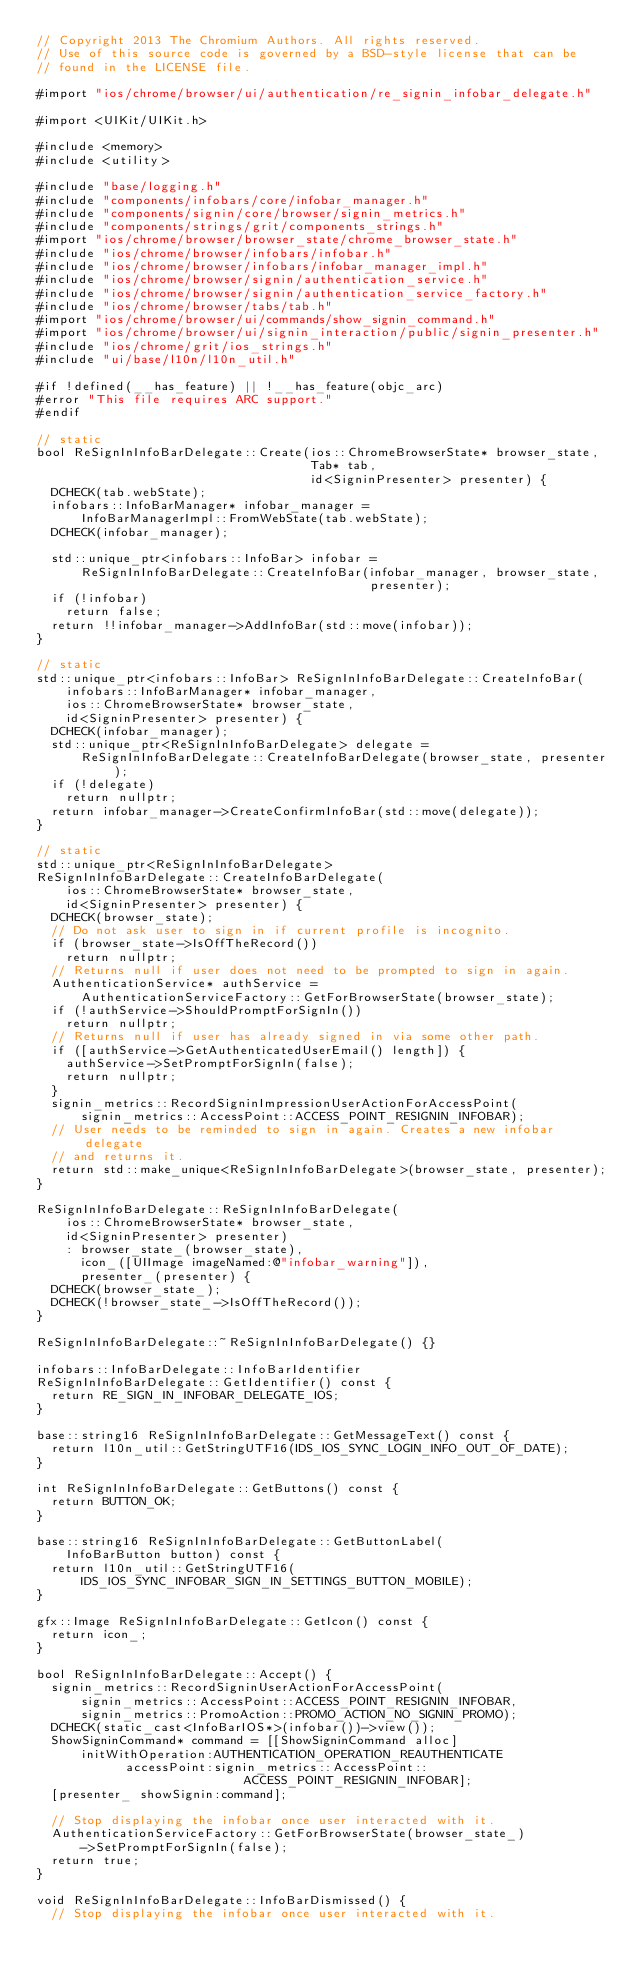<code> <loc_0><loc_0><loc_500><loc_500><_ObjectiveC_>// Copyright 2013 The Chromium Authors. All rights reserved.
// Use of this source code is governed by a BSD-style license that can be
// found in the LICENSE file.

#import "ios/chrome/browser/ui/authentication/re_signin_infobar_delegate.h"

#import <UIKit/UIKit.h>

#include <memory>
#include <utility>

#include "base/logging.h"
#include "components/infobars/core/infobar_manager.h"
#include "components/signin/core/browser/signin_metrics.h"
#include "components/strings/grit/components_strings.h"
#import "ios/chrome/browser/browser_state/chrome_browser_state.h"
#include "ios/chrome/browser/infobars/infobar.h"
#include "ios/chrome/browser/infobars/infobar_manager_impl.h"
#include "ios/chrome/browser/signin/authentication_service.h"
#include "ios/chrome/browser/signin/authentication_service_factory.h"
#include "ios/chrome/browser/tabs/tab.h"
#import "ios/chrome/browser/ui/commands/show_signin_command.h"
#import "ios/chrome/browser/ui/signin_interaction/public/signin_presenter.h"
#include "ios/chrome/grit/ios_strings.h"
#include "ui/base/l10n/l10n_util.h"

#if !defined(__has_feature) || !__has_feature(objc_arc)
#error "This file requires ARC support."
#endif

// static
bool ReSignInInfoBarDelegate::Create(ios::ChromeBrowserState* browser_state,
                                     Tab* tab,
                                     id<SigninPresenter> presenter) {
  DCHECK(tab.webState);
  infobars::InfoBarManager* infobar_manager =
      InfoBarManagerImpl::FromWebState(tab.webState);
  DCHECK(infobar_manager);

  std::unique_ptr<infobars::InfoBar> infobar =
      ReSignInInfoBarDelegate::CreateInfoBar(infobar_manager, browser_state,
                                             presenter);
  if (!infobar)
    return false;
  return !!infobar_manager->AddInfoBar(std::move(infobar));
}

// static
std::unique_ptr<infobars::InfoBar> ReSignInInfoBarDelegate::CreateInfoBar(
    infobars::InfoBarManager* infobar_manager,
    ios::ChromeBrowserState* browser_state,
    id<SigninPresenter> presenter) {
  DCHECK(infobar_manager);
  std::unique_ptr<ReSignInInfoBarDelegate> delegate =
      ReSignInInfoBarDelegate::CreateInfoBarDelegate(browser_state, presenter);
  if (!delegate)
    return nullptr;
  return infobar_manager->CreateConfirmInfoBar(std::move(delegate));
}

// static
std::unique_ptr<ReSignInInfoBarDelegate>
ReSignInInfoBarDelegate::CreateInfoBarDelegate(
    ios::ChromeBrowserState* browser_state,
    id<SigninPresenter> presenter) {
  DCHECK(browser_state);
  // Do not ask user to sign in if current profile is incognito.
  if (browser_state->IsOffTheRecord())
    return nullptr;
  // Returns null if user does not need to be prompted to sign in again.
  AuthenticationService* authService =
      AuthenticationServiceFactory::GetForBrowserState(browser_state);
  if (!authService->ShouldPromptForSignIn())
    return nullptr;
  // Returns null if user has already signed in via some other path.
  if ([authService->GetAuthenticatedUserEmail() length]) {
    authService->SetPromptForSignIn(false);
    return nullptr;
  }
  signin_metrics::RecordSigninImpressionUserActionForAccessPoint(
      signin_metrics::AccessPoint::ACCESS_POINT_RESIGNIN_INFOBAR);
  // User needs to be reminded to sign in again. Creates a new infobar delegate
  // and returns it.
  return std::make_unique<ReSignInInfoBarDelegate>(browser_state, presenter);
}

ReSignInInfoBarDelegate::ReSignInInfoBarDelegate(
    ios::ChromeBrowserState* browser_state,
    id<SigninPresenter> presenter)
    : browser_state_(browser_state),
      icon_([UIImage imageNamed:@"infobar_warning"]),
      presenter_(presenter) {
  DCHECK(browser_state_);
  DCHECK(!browser_state_->IsOffTheRecord());
}

ReSignInInfoBarDelegate::~ReSignInInfoBarDelegate() {}

infobars::InfoBarDelegate::InfoBarIdentifier
ReSignInInfoBarDelegate::GetIdentifier() const {
  return RE_SIGN_IN_INFOBAR_DELEGATE_IOS;
}

base::string16 ReSignInInfoBarDelegate::GetMessageText() const {
  return l10n_util::GetStringUTF16(IDS_IOS_SYNC_LOGIN_INFO_OUT_OF_DATE);
}

int ReSignInInfoBarDelegate::GetButtons() const {
  return BUTTON_OK;
}

base::string16 ReSignInInfoBarDelegate::GetButtonLabel(
    InfoBarButton button) const {
  return l10n_util::GetStringUTF16(
      IDS_IOS_SYNC_INFOBAR_SIGN_IN_SETTINGS_BUTTON_MOBILE);
}

gfx::Image ReSignInInfoBarDelegate::GetIcon() const {
  return icon_;
}

bool ReSignInInfoBarDelegate::Accept() {
  signin_metrics::RecordSigninUserActionForAccessPoint(
      signin_metrics::AccessPoint::ACCESS_POINT_RESIGNIN_INFOBAR,
      signin_metrics::PromoAction::PROMO_ACTION_NO_SIGNIN_PROMO);
  DCHECK(static_cast<InfoBarIOS*>(infobar())->view());
  ShowSigninCommand* command = [[ShowSigninCommand alloc]
      initWithOperation:AUTHENTICATION_OPERATION_REAUTHENTICATE
            accessPoint:signin_metrics::AccessPoint::
                            ACCESS_POINT_RESIGNIN_INFOBAR];
  [presenter_ showSignin:command];

  // Stop displaying the infobar once user interacted with it.
  AuthenticationServiceFactory::GetForBrowserState(browser_state_)
      ->SetPromptForSignIn(false);
  return true;
}

void ReSignInInfoBarDelegate::InfoBarDismissed() {
  // Stop displaying the infobar once user interacted with it.</code> 